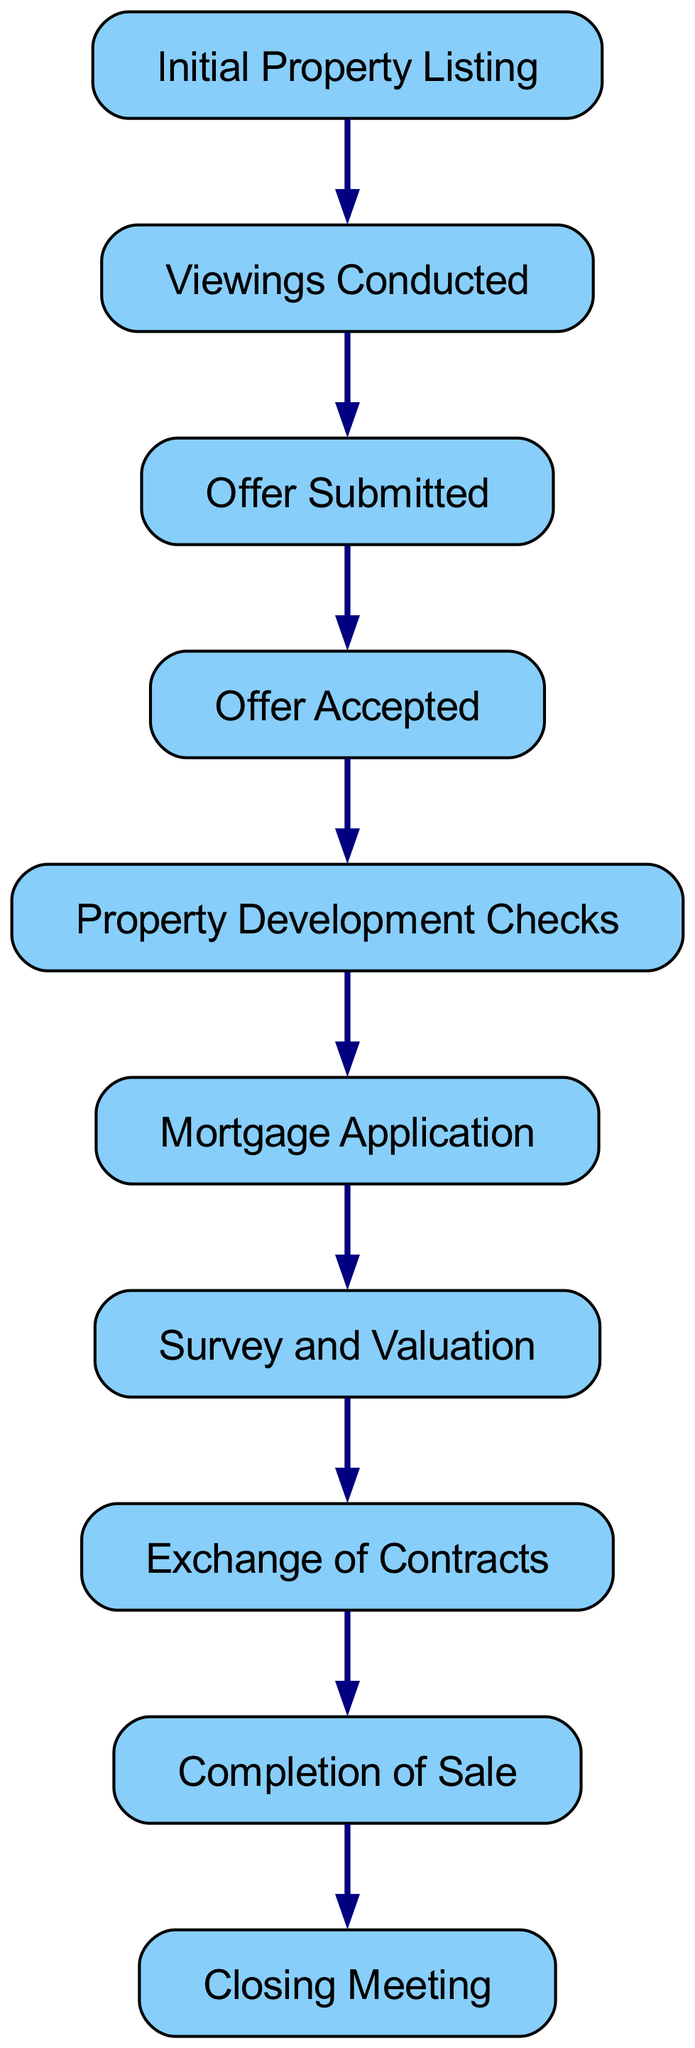What is the first step in a real estate transaction? The diagram indicates that the first step is the "Initial Property Listing" node, meaning it is the starting point of the transaction flow.
Answer: Initial Property Listing How many nodes are there in the transaction flowchart? By counting the unique elements labeled in the diagram, we find that there are 10 nodes indicating the key stages in the transaction.
Answer: 10 What is the last step before the closing meeting? The last step before the closing meeting is the "Completion of Sale" node, which directly precedes the "Closing Meeting" node in the flowchart.
Answer: Completion of Sale What follows after "Offer Accepted"? The diagram shows that "Property Development Checks" follow directly after "Offer Accepted," establishing the next required action or milestone in the transaction.
Answer: Property Development Checks Which nodes are directly connected without any intermediary nodes? By examining the diagram, we see that "Exchange of Contracts" and "Completion of Sale" are directly connected, indicating a straightforward transition without any other nodes intervening.
Answer: Exchange of Contracts and Completion of Sale How many edges connect the nodes in the diagram? The number of edges in the diagram corresponds to the connections between the nodes, which total to 9, representing the flow of the transaction stages.
Answer: 9 What document stage occurs after the "Mortgage Application"? The stage that follows "Mortgage Application" is "Survey and Valuation," as indicated by the direct link from one node to the other.
Answer: Survey and Valuation Which documents or actions must occur before "Exchange of Contracts"? The steps leading up to "Exchange of Contracts" include "Survey and Valuation" and "Mortgage Application," where both actions must take place prior to this legal milestone.
Answer: Survey and Valuation, Mortgage Application What is the relationship between "Viewings Conducted" and "Offer Submitted"? The relationship is direct; the diagram shows that "Offer Submitted" occurs immediately after "Viewings Conducted," indicating a sequential action in the transaction process.
Answer: Sequential action 